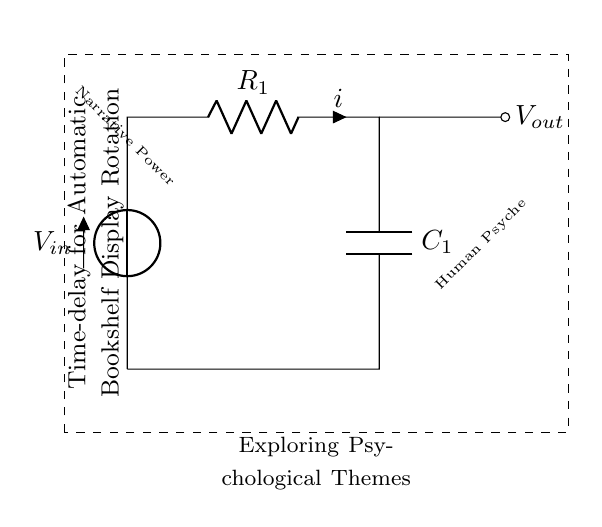What is the input voltage in this circuit? The input voltage is labeled as V_in at the top of the circuit diagram, indicating the point where the voltage is applied.
Answer: V_in What component stores energy in this circuit? The component that stores energy is identified as the capacitor, which is labeled C_1 in the diagram.
Answer: C_1 What is the function of resistor R_1? The resistor R_1 is used to limit the current flow in the circuit and works together with the capacitor to create a time delay effect.
Answer: Limit current What kind of circuit is this? This circuit is a resistor-capacitor circuit, which is commonly used for timing applications.
Answer: Resistor-Capacitor How does this circuit contribute to the display rotation system? This circuit provides a time delay, controlling how long the display remains on each psychological theme before rotating to another theme, which is crucial for showcasing narratives effectively.
Answer: Time delay What is the relationship between resistance and time delay in this circuit? The time delay is directly related to the resistance (R_1) and capacitance (C_1) values in the time constant formula, τ = R*C, where an increase in resistance leads to a longer time delay.
Answer: Time constant What is the output voltage's role in this setup? The output voltage, V_out, represents the voltage across the capacitor, and it indicates when the capacitor has charged to a specific level, subsequently controlling the timing of the display rotation.
Answer: Control timing 